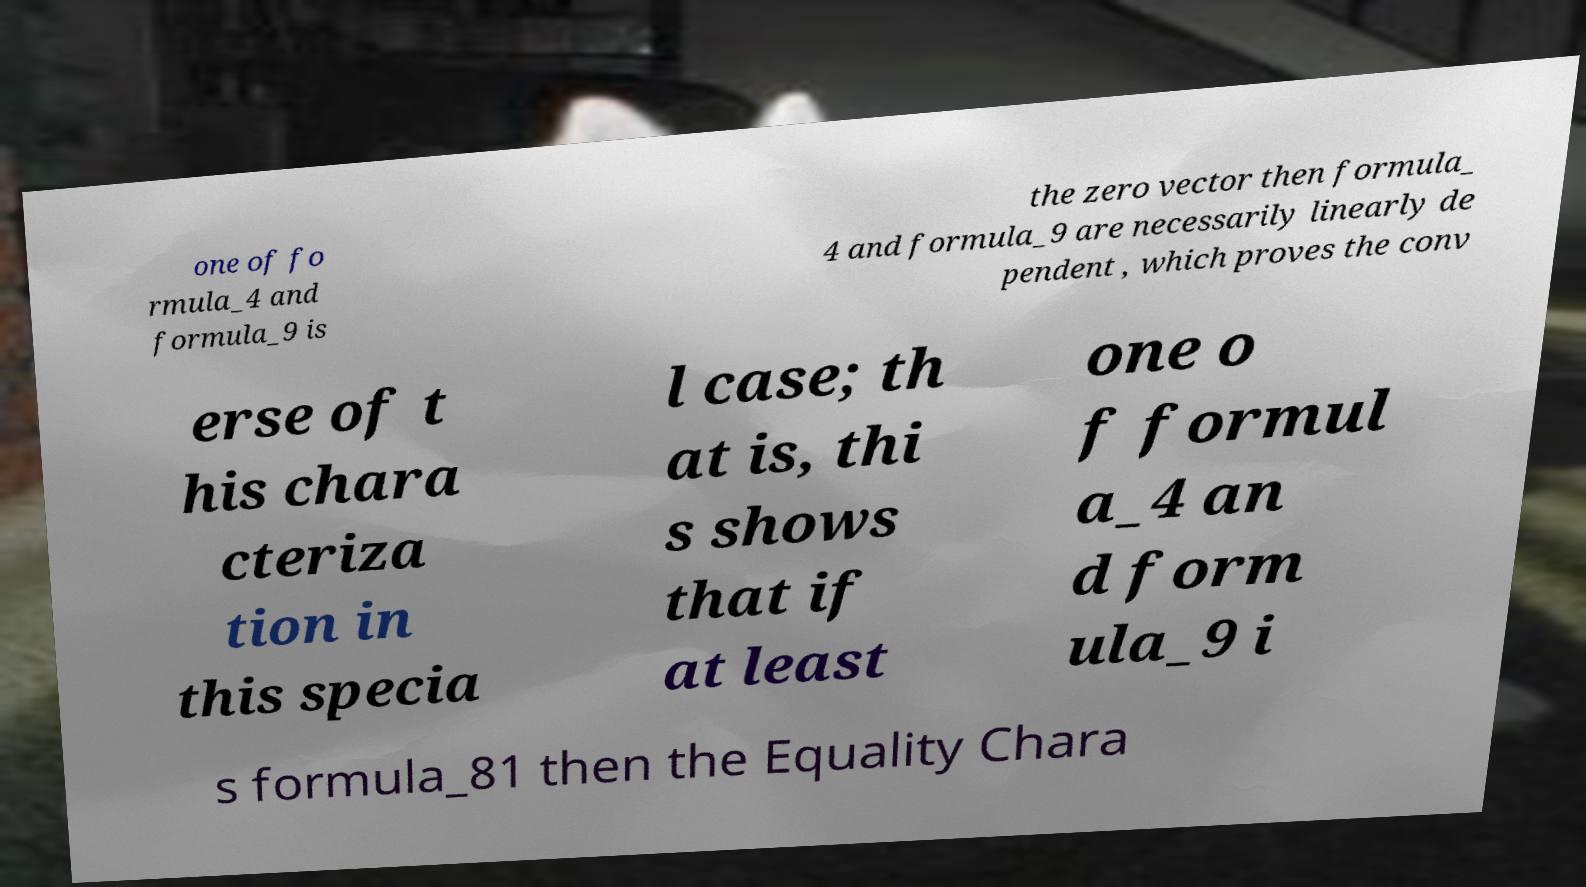Could you assist in decoding the text presented in this image and type it out clearly? one of fo rmula_4 and formula_9 is the zero vector then formula_ 4 and formula_9 are necessarily linearly de pendent , which proves the conv erse of t his chara cteriza tion in this specia l case; th at is, thi s shows that if at least one o f formul a_4 an d form ula_9 i s formula_81 then the Equality Chara 